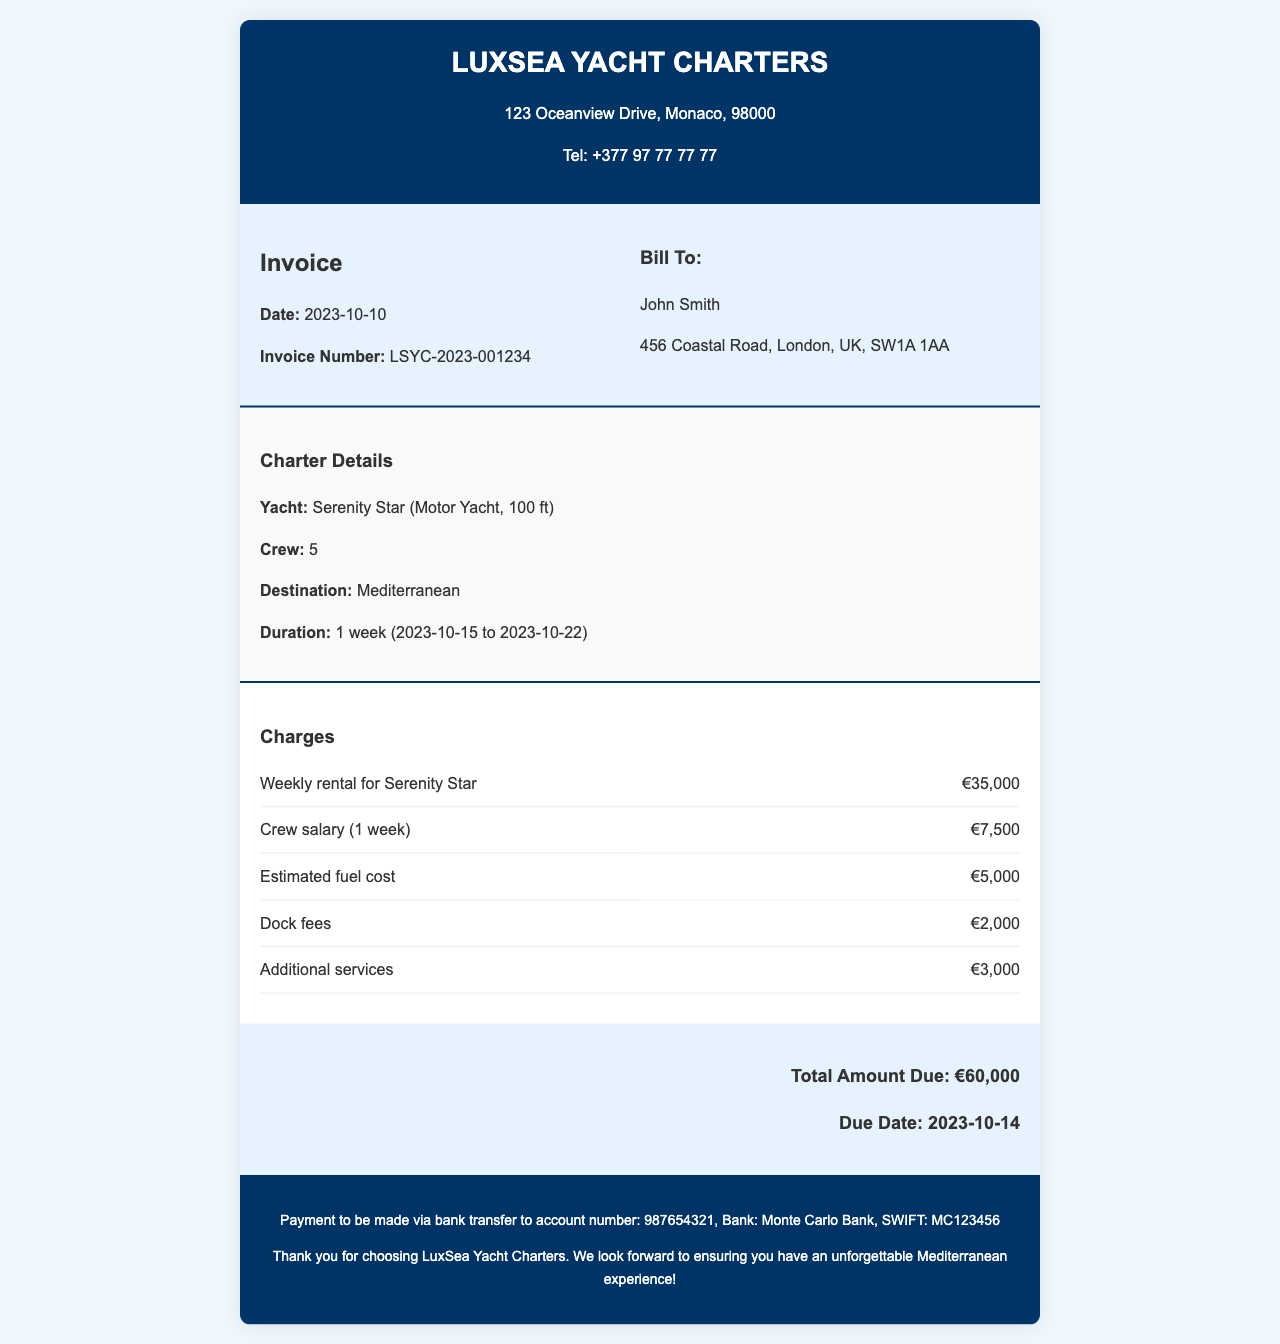What is the yacht name? The yacht name is stated explicitly in the charter details section of the document.
Answer: Serenity Star What is the total amount due? The total amount due is indicated at the bottom of the charges section.
Answer: €60,000 What is the duration of the charter? The duration is detailed in the charter details section, specifying the start and end dates.
Answer: 1 week (2023-10-15 to 2023-10-22) How many crew members are on board? The document lists the number of crew members in the charter details.
Answer: 5 What is the estimated fuel cost? The estimated fuel cost is specified in the charges section alongside other expenses.
Answer: €5,000 When is the payment due date? The due date for payment is mentioned in the total amount due section.
Answer: 2023-10-14 What is the address of LuxSea Yacht Charters? The address is provided in the header section of the invoice.
Answer: 123 Oceanview Drive, Monaco, 98000 What additional services charge? The charges for additional services are listed in the charges section of the document.
Answer: €3,000 What are dock fees? Dock fees are included as a specified charge in the charges section.
Answer: €2,000 